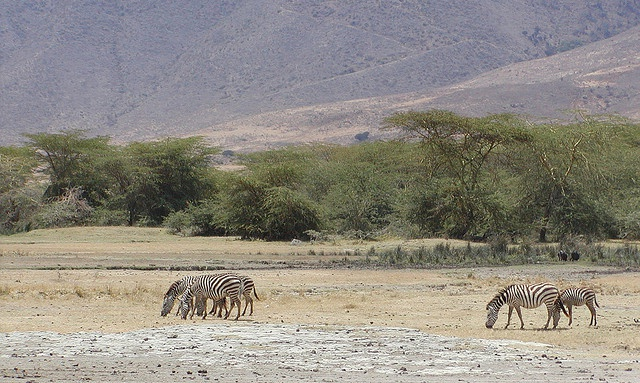Describe the objects in this image and their specific colors. I can see zebra in gray, black, darkgray, and ivory tones, zebra in gray, black, darkgray, and ivory tones, zebra in gray, black, maroon, and darkgray tones, and zebra in gray, black, darkgray, and maroon tones in this image. 